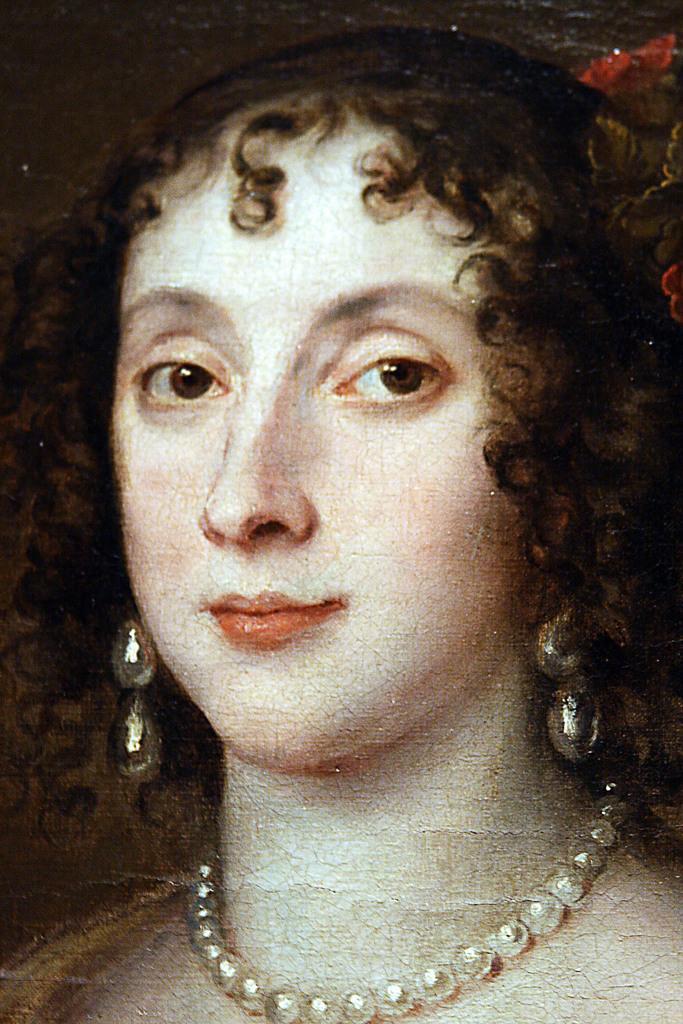Please provide a concise description of this image. In this image we can see the painting of a woman. 